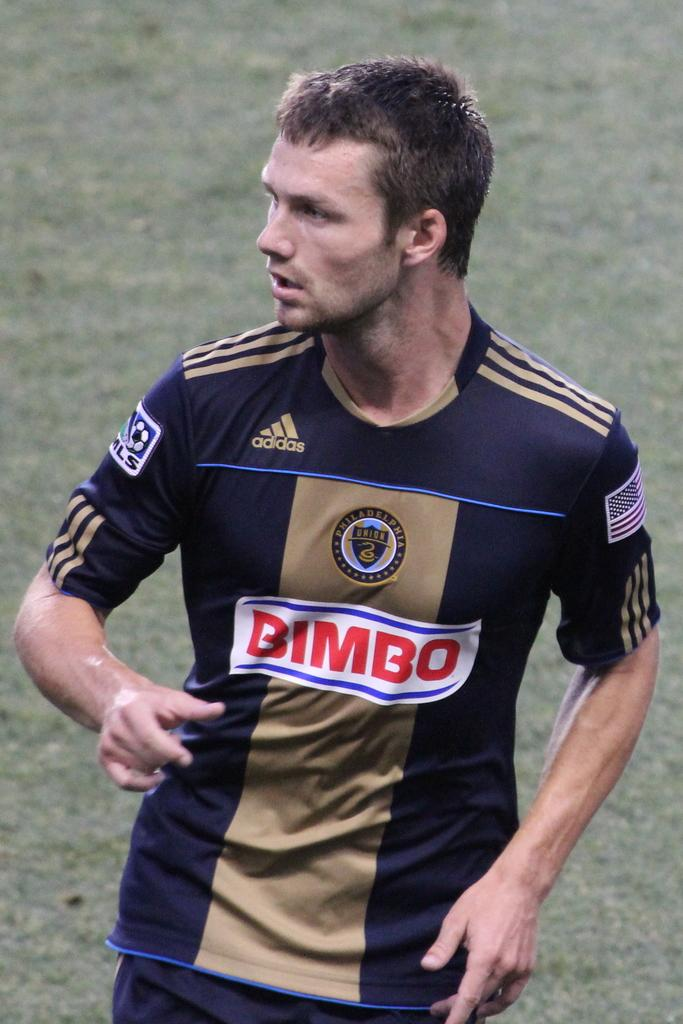<image>
Present a compact description of the photo's key features. A man wears a jersey that says BIMBO on the front. 